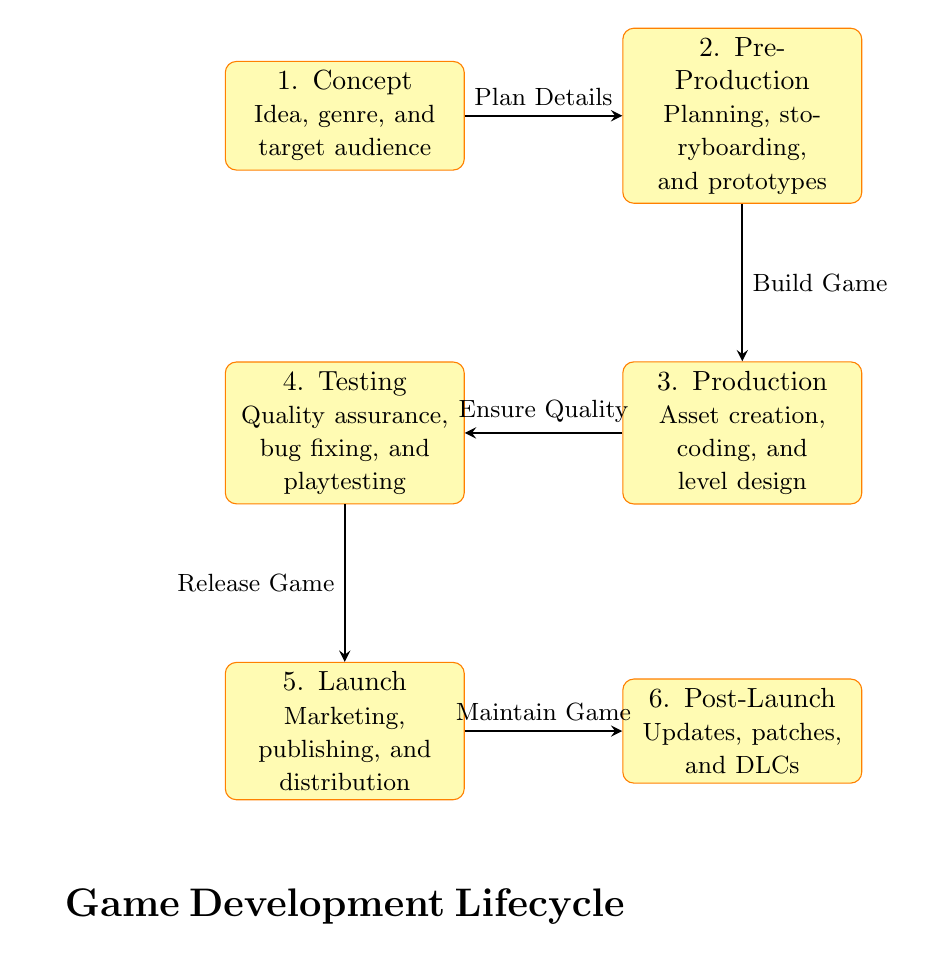What is the first stage of game development? The first stage is labeled as "1. Concept", indicating the initial phase where the idea, genre, and target audience are determined.
Answer: 1. Concept How many stages are there in the game development process? Counting all the nodes, there are six stages listed: Concept, Pre-Production, Production, Testing, Launch, and Post-Launch.
Answer: 6 What is the main focus of the Testing stage? The Testing stage is focused on quality assurance, bug fixing, and playtesting, as indicated in that section of the diagram.
Answer: Quality assurance, bug fixing, and playtesting What do you do after completing the Production stage? After Production, you proceed to the Testing stage, as shown by the arrow directing from Production to Testing.
Answer: Testing What is the last stage of game development? The last stage is labeled "6. Post-Launch," where updates, patches, and DLCs are managed following the official launch.
Answer: 6. Post-Launch Which stage involves marketing, publishing, and distribution? The Launch stage is responsible for marketing, publishing, and distribution, as described in its label in the diagram.
Answer: Launch What is the relationship between Pre-Production and Production? The relationship is a direct flow where Pre-Production leads to Production, indicated by the arrow labeled "Build Game."
Answer: Build Game What step is taken after Testing? Upon completing Testing, the next step is to Release the Game, as illustrated by the arrow connecting Testing to Launch.
Answer: Release Game What happens during the Post-Launch stage according to the diagram? In the Post-Launch stage, the focus is on maintaining the game with updates, patches, and DLCs. This is described in the stage's detail.
Answer: Updates, patches, and DLCs 